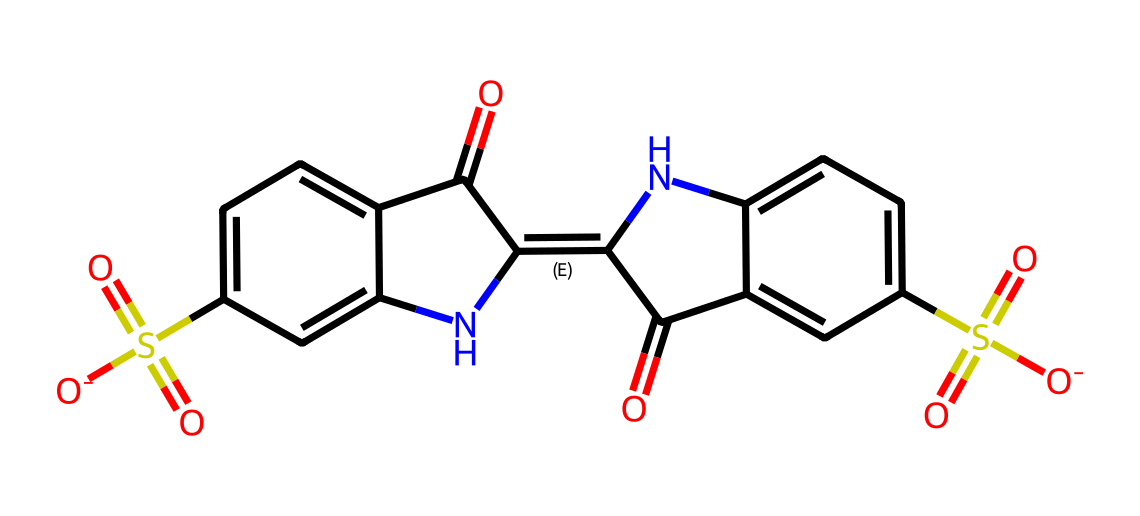What is the core functional group present in this dye? The core functional group can be identified by looking for the sulfonate and carbonyl groups within the structure. In this case, the sulfonate group (O=S(=O)([O-])) indicates it's a sulfonic acid derivative, which is critical in dyes for their water solubility.
Answer: sulfonate How many carbon atoms are in this chemical structure? By analyzing the SMILES notation, we can count the number of carbon atoms present. Each carbon atom is represented in the structure, and sequentially counting leads to identifying a total of 18 carbon atoms in the given structure.
Answer: 18 What types of rings are found in this dye? Observing the chemical structure from the SMILES representation, we can see the presence of aromatic rings due to the notation "c" and "C" which indicate carbon atoms in a ring structure. Here there are multiple fused and non-fused aromatic rings.
Answer: fused and non-fused aromatic What is the charge present in this dye molecule? Looking at the SMILES, we can identify the negatively charged sulfonate group represented by the notation [O-]. This indicates the presence of a charge in this chemical, specifically a negative charge.
Answer: negative How many nitrogen atoms are present in this dye? In the SMILES, nitrogen atoms are shown by the letter 'N'. Counting these within the chemical structure reveals a total of 2 nitrogen atoms, which are part of the dye's core structure.
Answer: 2 What property does the presence of a sulfonate group impart to the dye? The presence of a sulfonate group enhances the dye's solubility in water, resulting in improving the dye's ability to easily blend with water-based fabrics. This quality is particularly advantageous in eco-friendly dye applications.
Answer: water solubility What is the primary use of this dye in sustainable film costumes? This dye, being eco-friendly, is primarily used in sustainable film costumes to provide color without harming the environment, effectively meeting both aesthetic and environmental needs in costume design.
Answer: color 